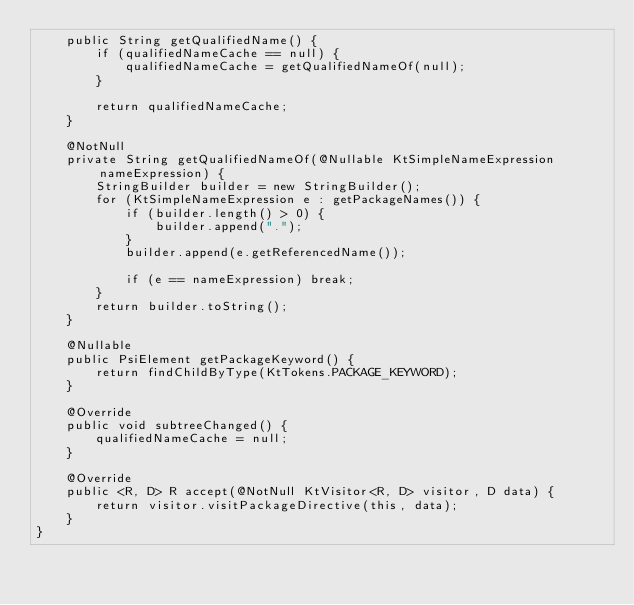<code> <loc_0><loc_0><loc_500><loc_500><_Java_>    public String getQualifiedName() {
        if (qualifiedNameCache == null) {
            qualifiedNameCache = getQualifiedNameOf(null);
        }

        return qualifiedNameCache;
    }

    @NotNull
    private String getQualifiedNameOf(@Nullable KtSimpleNameExpression nameExpression) {
        StringBuilder builder = new StringBuilder();
        for (KtSimpleNameExpression e : getPackageNames()) {
            if (builder.length() > 0) {
                builder.append(".");
            }
            builder.append(e.getReferencedName());

            if (e == nameExpression) break;
        }
        return builder.toString();
    }

    @Nullable
    public PsiElement getPackageKeyword() {
        return findChildByType(KtTokens.PACKAGE_KEYWORD);
    }

    @Override
    public void subtreeChanged() {
        qualifiedNameCache = null;
    }

    @Override
    public <R, D> R accept(@NotNull KtVisitor<R, D> visitor, D data) {
        return visitor.visitPackageDirective(this, data);
    }
}

</code> 